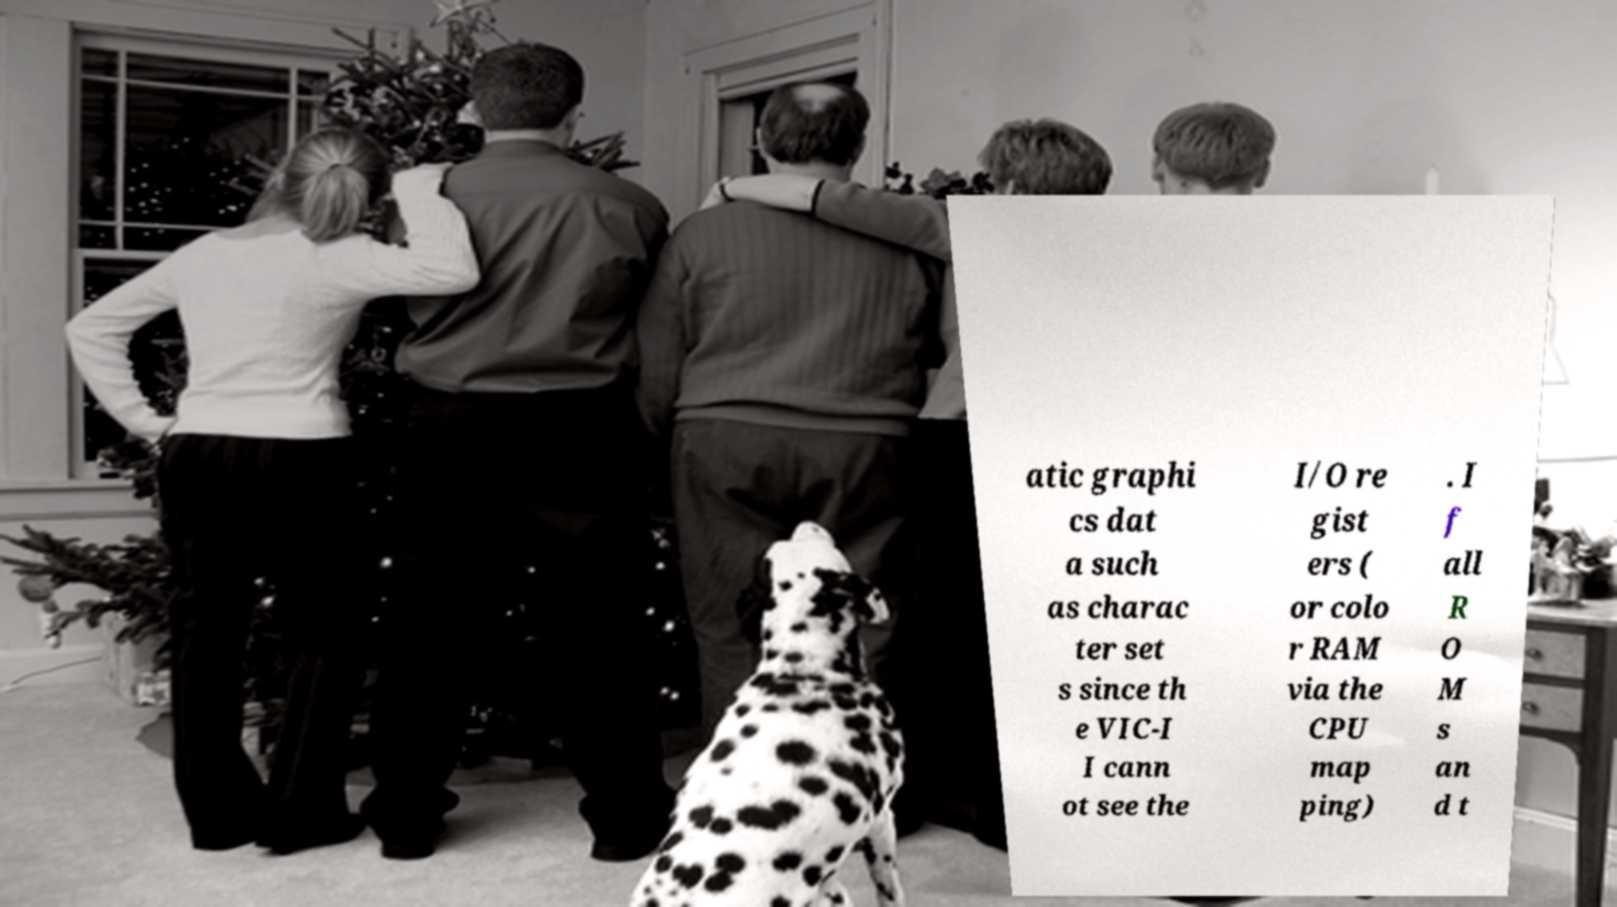Can you accurately transcribe the text from the provided image for me? atic graphi cs dat a such as charac ter set s since th e VIC-I I cann ot see the I/O re gist ers ( or colo r RAM via the CPU map ping) . I f all R O M s an d t 